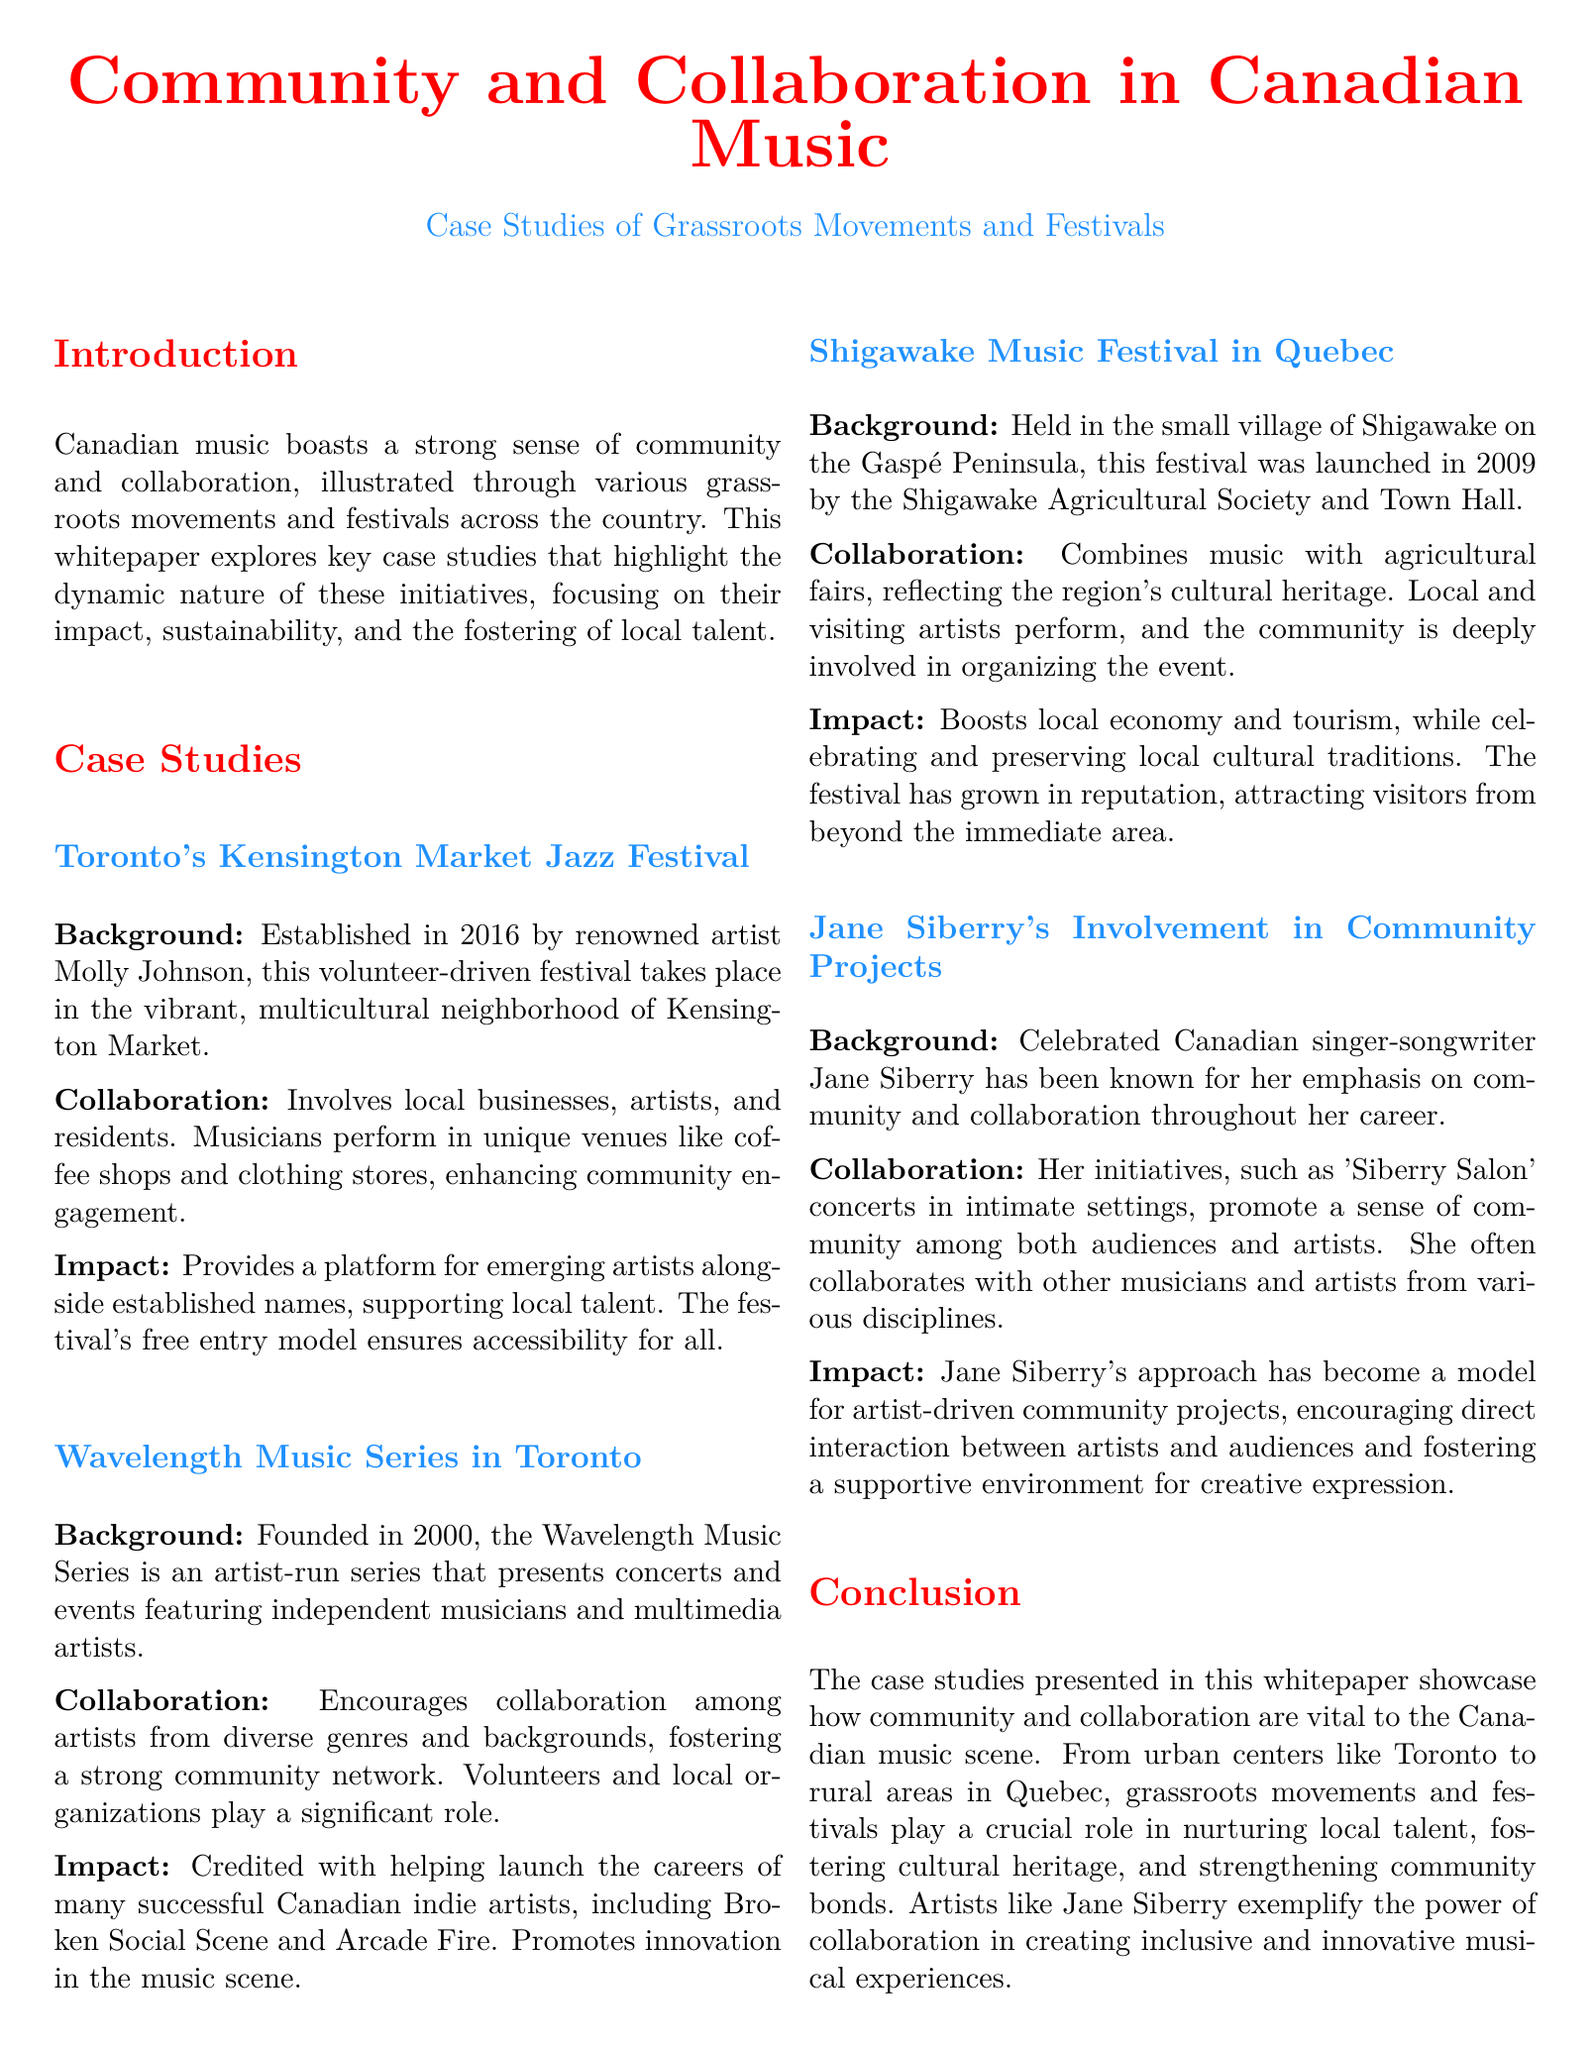What year was the Kensington Market Jazz Festival established? The document states that the Kensington Market Jazz Festival was established in 2016.
Answer: 2016 Who founded the Wavelength Music Series? The document mentions that the Wavelength Music Series was founded by artists in 2000.
Answer: Artists What is the primary theme of Jane Siberry's community projects? The document highlights that Jane Siberry's community projects emphasize collaboration.
Answer: Collaboration In which province is the Shigawake Music Festival located? The document specifies that the Shigawake Music Festival is held in Quebec.
Answer: Quebec How many years has the Wavelength Music Series been active as of 2023? The document indicates the Wavelength Music Series was founded in 2000, and as of 2023, it has been active for 23 years.
Answer: 23 years What type of venues are used for performances in Kensington Market Jazz Festival? The document states that musicians perform in unique venues like coffee shops and clothing stores.
Answer: Coffee shops and clothing stores What is one impact of the Shigawake Music Festival mentioned in the document? The document states that one impact is boosting the local economy and tourism.
Answer: Boosts local economy and tourism Which Toronto festival supports local talent alongside established names? The document specifies that the Kensington Market Jazz Festival provides a platform for emerging artists alongside established names.
Answer: Kensington Market Jazz Festival What role do volunteers play in the Wavelength Music Series? The document highlights that volunteers play a significant role in the Wavelength Music Series.
Answer: Significant role 